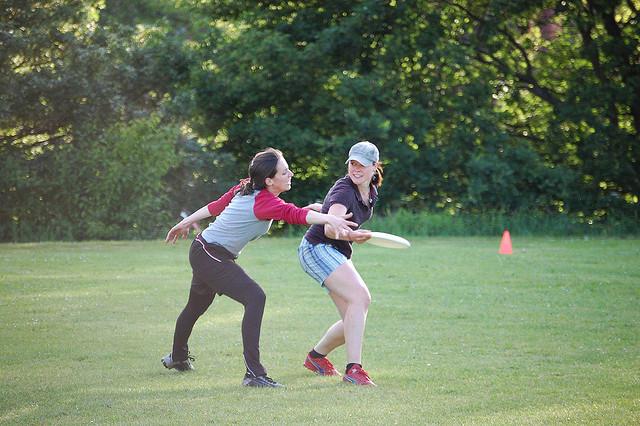How many people are posing for the picture?
Short answer required. 2. What game is this?
Short answer required. Frisbee. What are the women doing?
Give a very brief answer. Playing frisbee. Is the girl in the shade?
Write a very short answer. Yes. What color are the girl's clothes?
Give a very brief answer. Blue, purple, red, grey black. What is she throwing?
Concise answer only. Frisbee. Why do the young men have ethereal doubles?
Write a very short answer. Can't tell. How can you tell this is not a professional team?
Keep it brief. No uniforms. How many orange cones are visible?
Answer briefly. 1. 